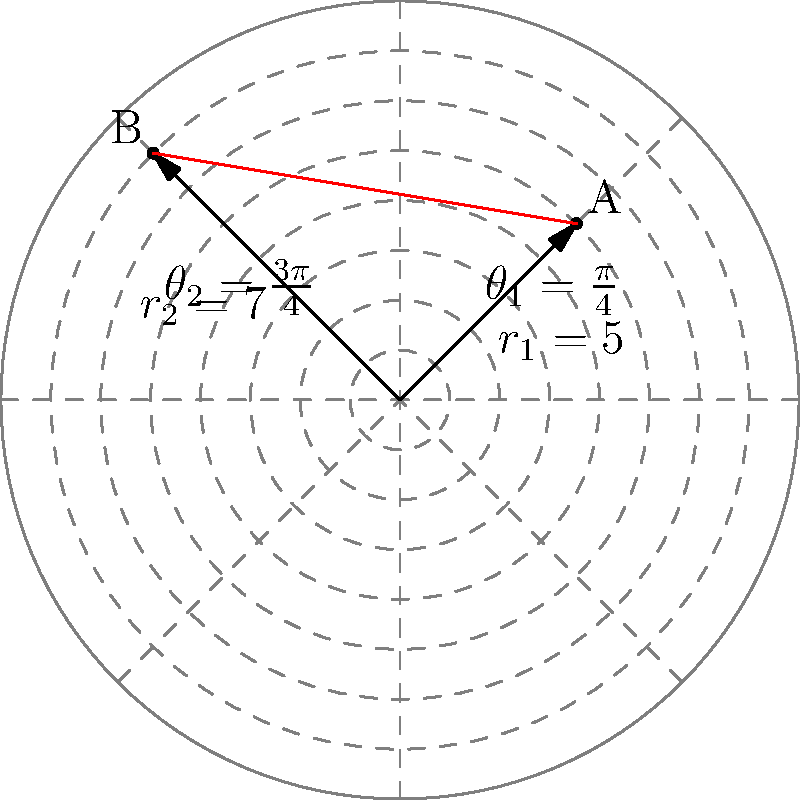As a business owner managing trade networks between South Asian countries, you need to calculate the shortest distance between two trade hubs. Hub A is located at $(r_1, \theta_1) = (5, \frac{\pi}{4})$ and Hub B is at $(r_2, \theta_2) = (7, \frac{3\pi}{4})$ in polar coordinates. Calculate the shortest distance between these two hubs. To find the shortest distance between two points in polar coordinates, we can use the following steps:

1. Convert the polar coordinates to Cartesian coordinates:
   For Hub A: $x_1 = r_1 \cos(\theta_1)$, $y_1 = r_1 \sin(\theta_1)$
   For Hub B: $x_2 = r_2 \cos(\theta_2)$, $y_2 = r_2 \sin(\theta_2)$

2. Calculate the coordinates:
   Hub A: $x_1 = 5 \cos(\frac{\pi}{4}) = \frac{5}{\sqrt{2}}$, $y_1 = 5 \sin(\frac{\pi}{4}) = \frac{5}{\sqrt{2}}$
   Hub B: $x_2 = 7 \cos(\frac{3\pi}{4}) = -\frac{7}{\sqrt{2}}$, $y_2 = 7 \sin(\frac{3\pi}{4}) = \frac{7}{\sqrt{2}}$

3. Use the distance formula between two points in Cartesian coordinates:
   $d = \sqrt{(x_2 - x_1)^2 + (y_2 - y_1)^2}$

4. Substitute the values:
   $d = \sqrt{(-\frac{7}{\sqrt{2}} - \frac{5}{\sqrt{2}})^2 + (\frac{7}{\sqrt{2}} - \frac{5}{\sqrt{2}})^2}$

5. Simplify:
   $d = \sqrt{(\frac{-12}{\sqrt{2}})^2 + (\frac{2}{\sqrt{2}})^2}$
   $d = \sqrt{\frac{144}{2} + \frac{4}{2}} = \sqrt{\frac{148}{2}} = \sqrt{74} \approx 8.602$

Thus, the shortest distance between the two trade hubs is $\sqrt{74}$ units.
Answer: $\sqrt{74}$ units 